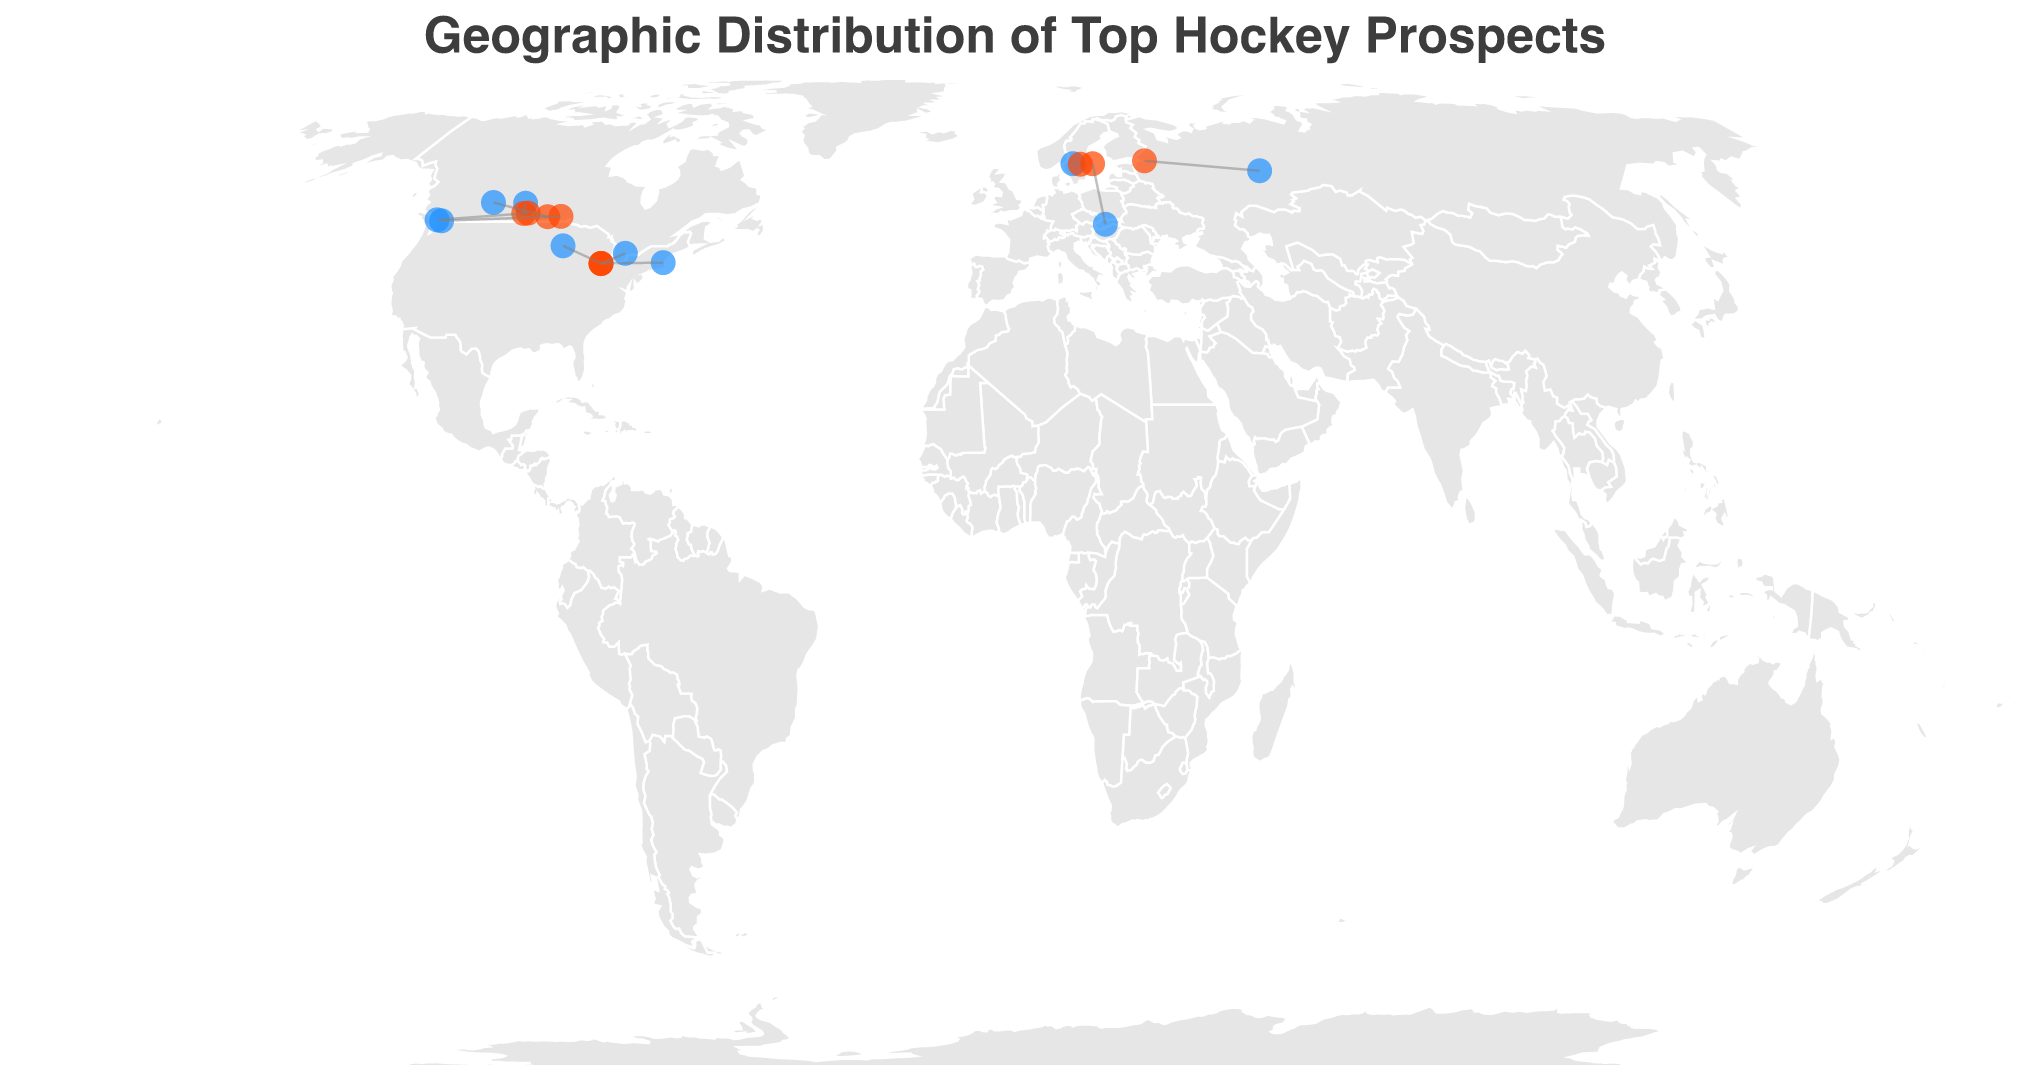What's the title of the figure? The title of the figure is usually positioned at the top and can be found there. In this case, the title reads "Geographic Distribution of Top Hockey Prospects".
Answer: Geographic Distribution of Top Hockey Prospects Which color represents the birthplaces of the players on the map? By looking at the visual elements, the birthplaces are marked with blue circles, as specified in the legend and referring to #1e90ff.
Answer: Blue How many players have their birthplace marked in Canada? By counting the blue circles within the geographical boundaries of Canada, we see that Connor Bedard, Adam Fantilli, Zach Benson, Brayden Yager, and Nate Danielson originate from there.
Answer: 5 What is the Player and Current Team for the point located around latitude 58.0105 and longitude 56.2502? We can pinpoint this location on the map, and the tooltip or the data indicates it corresponds to Matvei Michkov who plays for SKA Saint Petersburg.
Answer: Matvei Michkov, SKA Saint Petersburg Which player has the shortest geographical distance between their birthplace and current team? To determine this, we visually compare the lines connecting circles to see which is the shortest. Out of the shown data, Leo Carlsson (Karlstad to Örebro HK) has the shortest distance.
Answer: Leo Carlsson Which player has the longest distance between their birthplace and current team? We need to look for the longest line connecting two circles, which appears to be Adam Fantilli, traveling from Nobleton to the University of Michigan.
Answer: Adam Fantilli What is the total number of unique teams represented on this plot? By inspecting the red circles and counting different team names, we identify the following teams: Regina Pats, University of Michigan, Örebro HK, SKA Saint Petersburg, Winnipeg Ice, USA U18, AIK, Moose Jaw Warriors, and Brandon Wheat Kings.
Answer: 9 Are there any players from the USA, and if so, which teams are they currently playing for? Checking the birthplace data corresponding to USA locations and following their current team on the map: Will Smith (Lexington) and Oliver Moore (Mounds View) both play for USA U18.
Answer: USA U18 Which player's birthplace and current team are both in Europe? By identifying European locations in the latitude/longitude data and matching birthplace and current team locations, we find Leo Carlsson (Karlstad and Örebro HK) and Dalibor Dvorsky (Zvolen and AIK) both fulfill this condition.
Answer: Leo Carlsson, Dalibor Dvorsky 